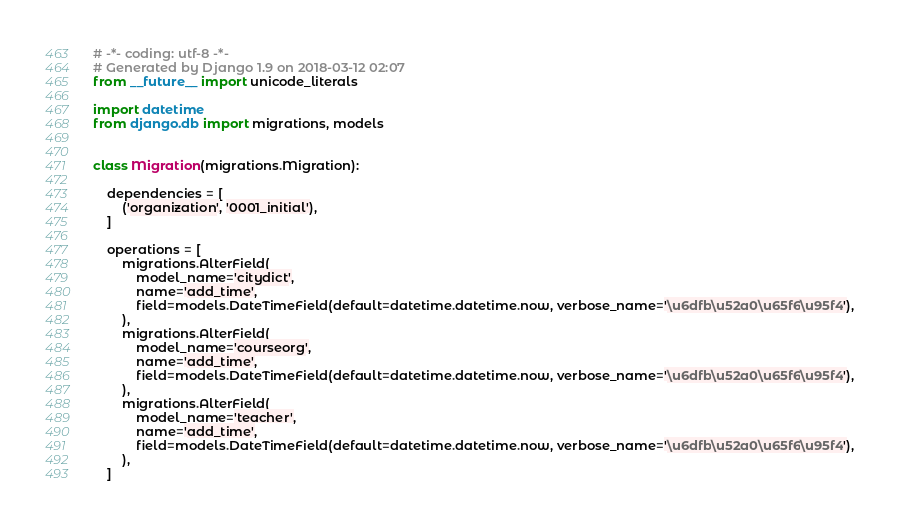Convert code to text. <code><loc_0><loc_0><loc_500><loc_500><_Python_># -*- coding: utf-8 -*-
# Generated by Django 1.9 on 2018-03-12 02:07
from __future__ import unicode_literals

import datetime
from django.db import migrations, models


class Migration(migrations.Migration):

    dependencies = [
        ('organization', '0001_initial'),
    ]

    operations = [
        migrations.AlterField(
            model_name='citydict',
            name='add_time',
            field=models.DateTimeField(default=datetime.datetime.now, verbose_name='\u6dfb\u52a0\u65f6\u95f4'),
        ),
        migrations.AlterField(
            model_name='courseorg',
            name='add_time',
            field=models.DateTimeField(default=datetime.datetime.now, verbose_name='\u6dfb\u52a0\u65f6\u95f4'),
        ),
        migrations.AlterField(
            model_name='teacher',
            name='add_time',
            field=models.DateTimeField(default=datetime.datetime.now, verbose_name='\u6dfb\u52a0\u65f6\u95f4'),
        ),
    ]
</code> 